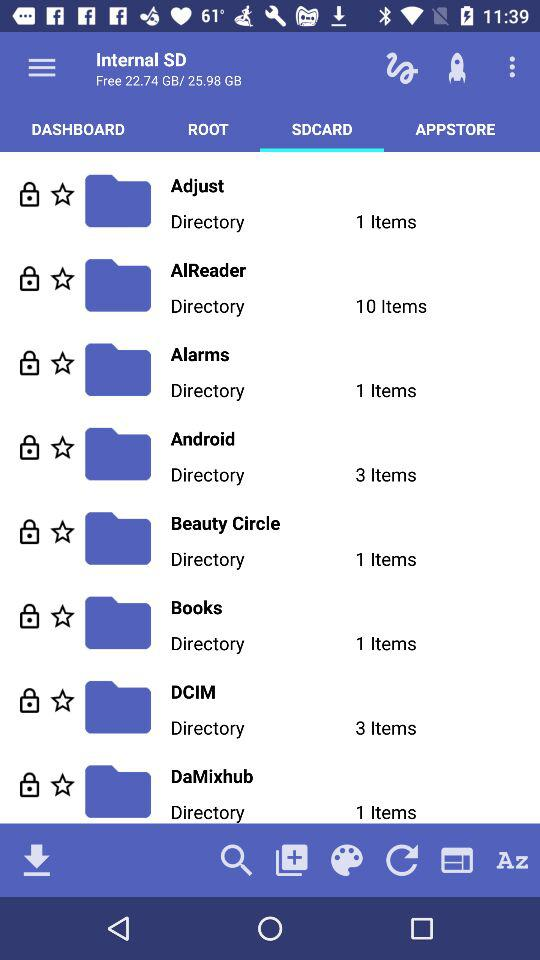What is the total internal storage of the SD card? The total storage capacity of the SD card is 25.98 GB. 